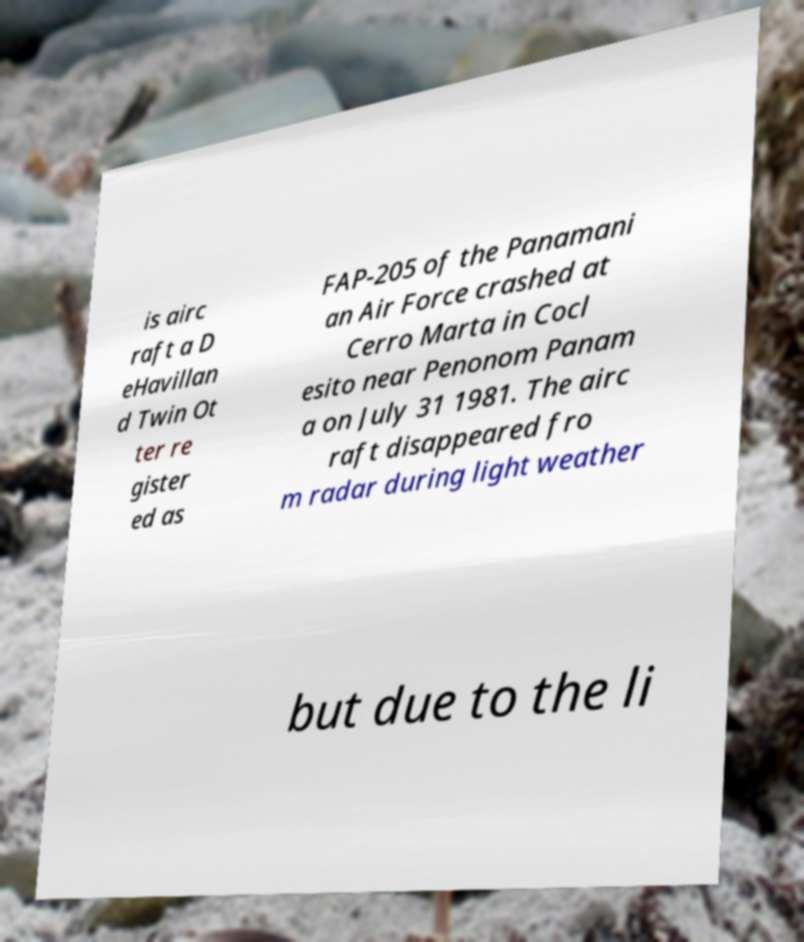What messages or text are displayed in this image? I need them in a readable, typed format. is airc raft a D eHavillan d Twin Ot ter re gister ed as FAP-205 of the Panamani an Air Force crashed at Cerro Marta in Cocl esito near Penonom Panam a on July 31 1981. The airc raft disappeared fro m radar during light weather but due to the li 